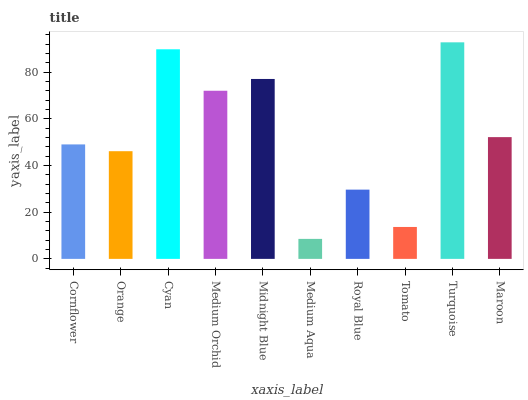Is Medium Aqua the minimum?
Answer yes or no. Yes. Is Turquoise the maximum?
Answer yes or no. Yes. Is Orange the minimum?
Answer yes or no. No. Is Orange the maximum?
Answer yes or no. No. Is Cornflower greater than Orange?
Answer yes or no. Yes. Is Orange less than Cornflower?
Answer yes or no. Yes. Is Orange greater than Cornflower?
Answer yes or no. No. Is Cornflower less than Orange?
Answer yes or no. No. Is Maroon the high median?
Answer yes or no. Yes. Is Cornflower the low median?
Answer yes or no. Yes. Is Medium Orchid the high median?
Answer yes or no. No. Is Cyan the low median?
Answer yes or no. No. 